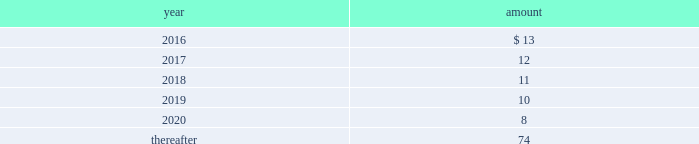Long-term liabilities .
The value of the company 2019s deferred compensation obligations is based on the market value of the participants 2019 notional investment accounts .
The notional investments are comprised primarily of mutual funds , which are based on observable market prices .
Mark-to-market derivative asset and liability 2014the company utilizes fixed-to-floating interest-rate swaps , typically designated as fair-value hedges , to achieve a targeted level of variable-rate debt as a percentage of total debt .
The company also employs derivative financial instruments in the form of variable-to-fixed interest rate swaps , classified as economic hedges , in order to fix the interest cost on some of its variable-rate debt .
The company uses a calculation of future cash inflows and estimated future outflows , which are discounted , to determine the current fair value .
Additional inputs to the present value calculation include the contract terms , counterparty credit risk , interest rates and market volatility .
Other investments 2014other investments primarily represent money market funds used for active employee benefits .
The company includes other investments in other current assets .
Note 18 : leases the company has entered into operating leases involving certain facilities and equipment .
Rental expenses under operating leases were $ 21 for 2015 , $ 22 for 2014 and $ 23 for 2013 .
The operating leases for facilities will expire over the next 25 years and the operating leases for equipment will expire over the next five years .
Certain operating leases have renewal options ranging from one to five years .
The minimum annual future rental commitment under operating leases that have initial or remaining non- cancelable lease terms over the next five years and thereafter are as follows: .
The company has a series of agreements with various public entities ( the 201cpartners 201d ) to establish certain joint ventures , commonly referred to as 201cpublic-private partnerships . 201d under the public-private partnerships , the company constructed utility plant , financed by the company and the partners constructed utility plant ( connected to the company 2019s property ) , financed by the partners .
The company agreed to transfer and convey some of its real and personal property to the partners in exchange for an equal principal amount of industrial development bonds ( 201cidbs 201d ) , issued by the partners under a state industrial development bond and commercial development act .
The company leased back the total facilities , including portions funded by both the company and the partners , under leases for a period of 40 years .
The leases related to the portion of the facilities funded by the company have required payments from the company to the partners that approximate the payments required by the terms of the idbs from the partners to the company ( as the holder of the idbs ) .
As the ownership of the portion of the facilities constructed by the company will revert back to the company at the end of the lease , the company has recorded these as capital leases .
The lease obligation and the receivable for the principal amount of the idbs are presented by the company on a net basis .
The gross cost of the facilities funded by the company recognized as a capital lease asset was $ 156 and $ 157 as of december 31 , 2015 and 2014 , respectively , which is presented in property , plant and equipment in the accompanying consolidated balance sheets .
The future payments under the lease obligations are equal to and offset by the payments receivable under the idbs. .
What was the amortization expense for the operating leases for facility and equipment from 2015 to 2014 in dollars? 
Rationale: the change from one period to another is the difference between the 2 periods
Computations: (22 - 21)
Answer: 1.0. 